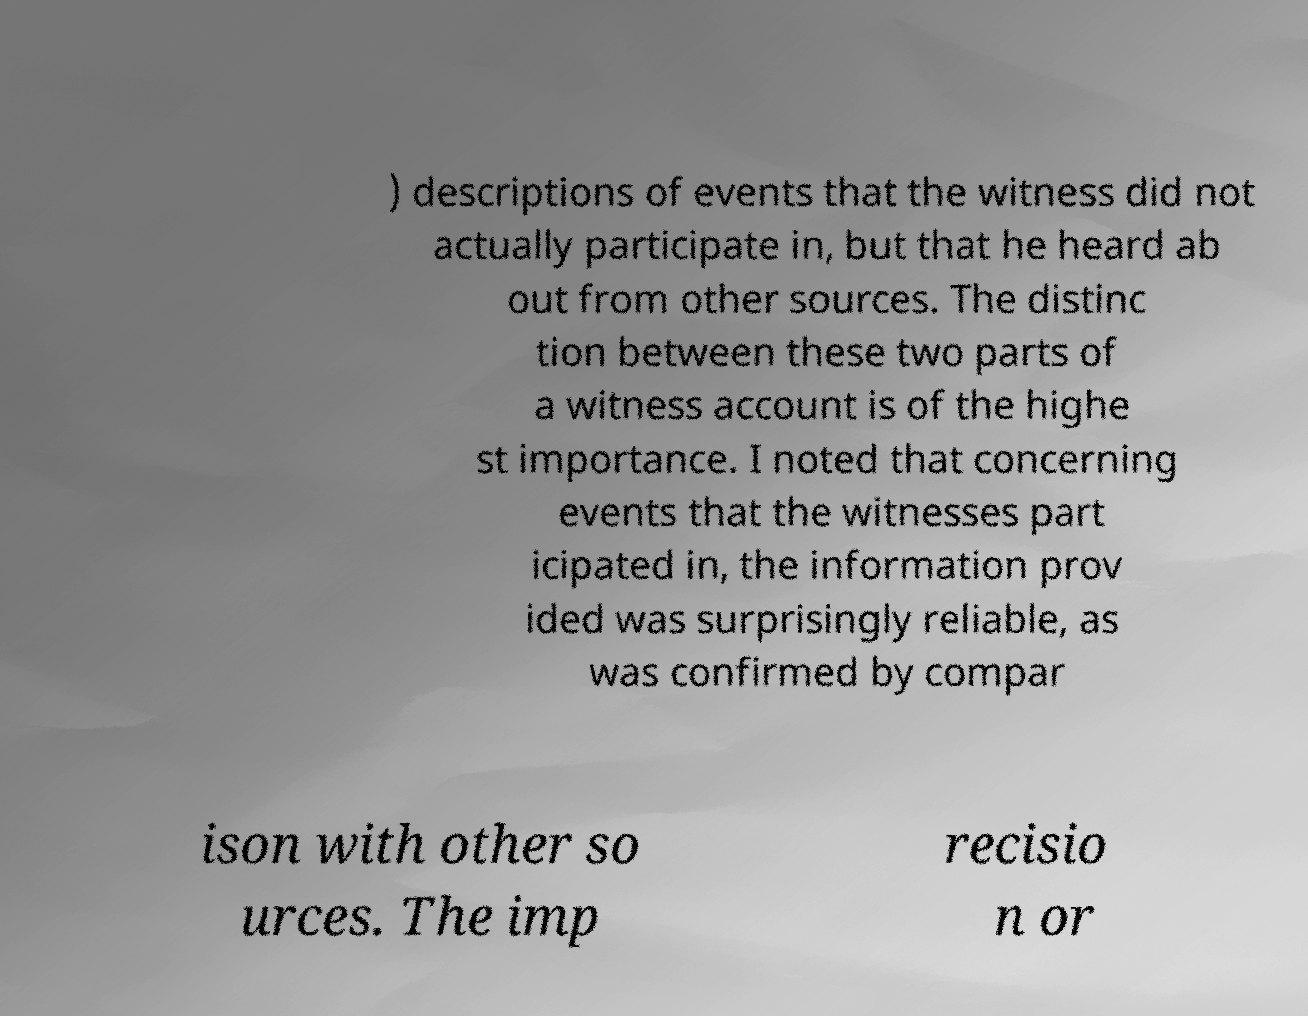Can you read and provide the text displayed in the image?This photo seems to have some interesting text. Can you extract and type it out for me? ) descriptions of events that the witness did not actually participate in, but that he heard ab out from other sources. The distinc tion between these two parts of a witness account is of the highe st importance. I noted that concerning events that the witnesses part icipated in, the information prov ided was surprisingly reliable, as was confirmed by compar ison with other so urces. The imp recisio n or 